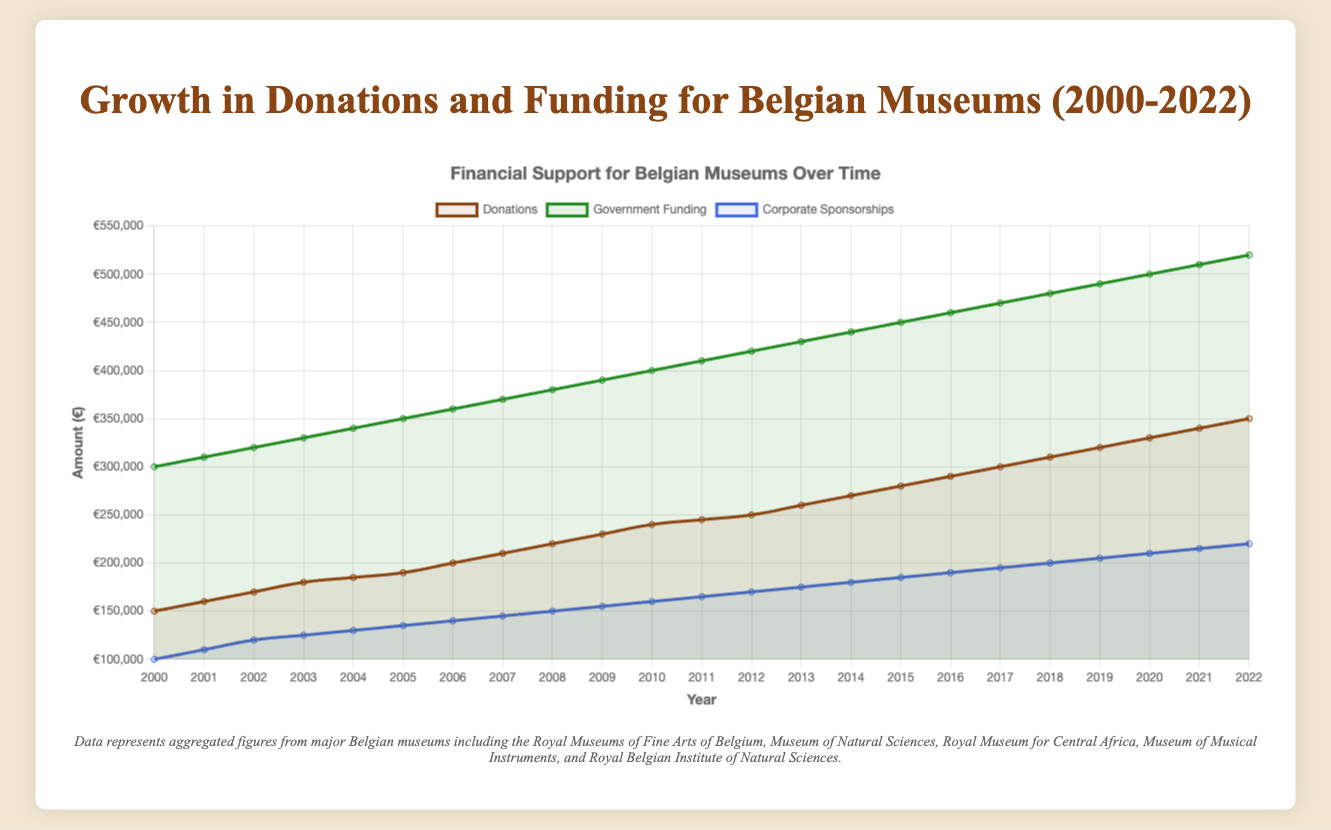What was the total amount of financial support (donations, government funding, and corporate sponsorships) for Belgian museums in 2010? To find the total financial support in 2010, sum up the donations, government funding, and corporate sponsorships for that year: 240,000 + 400,000 + 160,000 = 800,000 €
Answer: 800,000 € Between 2000 and 2022, which type of financial support saw the steepest growth? Compare the increase in donations, government funding, and corporate sponsorships from 2000 to 2022. Donations increased by 200,000 €, government funding by 220,000 €, and corporate sponsorships by 120,000 €. The steepest growth is in government funding.
Answer: Government funding Which year had the highest corporate sponsorships? Look through the data of corporate sponsorships from 2000 to 2022. The highest is in 2022 with 220,000 €.
Answer: 2022 How did donations compare to government funding in 2012? Compare the amounts of donations and government funding in 2012. Donations were 250,000 €, and government funding was 420,000 €, so government funding was higher.
Answer: Government funding was higher What was the average annual government funding between 2000 and 2022? Compute the average government funding by summing all annual government funding amounts from 2000 to 2022 and then dividing by the number of years (23 years): (300,000 + 310,000 + 320,000 + 330,000 + 340,000 + 350,000 + 360,000 + 370,000 + 380,000 + 390,000 + 400,000 + 410,000 + 420,000 + 430,000 + 440,000 + 450,000 + 460,000 + 470,000 + 480,000 + 490,000 + 500,000 + 510,000 + 520,000) / 23 ≈ 413,043.48 €
Answer: 413,043.48 € What is the median amount of corporate sponsorships from 2000 to 2022? To find the median, list the corporate sponsorship amounts from all years in ascending order, then find the middle value. The middle value in a set of 23 numbers is the 12th number when sorted: 100,000, 110,000, 120,000, 125,000, 130,000, 135,000, 140,000, 145,000, 150,000, 155,000, 160,000, (165,000), 170,000, 175,000, 180,000, 185,000, 190,000, 195,000, 200,000, 205,000, 210,000, 215,000, 220,000
Answer: 165,000 € How much did government funding increase from 2000 to 2022? Subtract the government funding in 2000 from the amount in 2022: 520,000 - 300,000 = 220,000 €
Answer: 220,000 € Which source of financial support had the smallest increase between 2000 and 2022? Compare the increase for each type of financial support from 2000 to 2022. Donations increased by 200,000 €, government funding by 220,000 €, and corporate sponsorships by 120,000 €. So, the smallest increase is in corporate sponsorships.
Answer: Corporate sponsorships What percentage of the total financial support in 2020 was contributed by donations? First, calculate the total financial support in 2020: 330,000 + 500,000 + 210,000 = 1,040,000 €. Then, divide the donations by the total and multiply by 100 to get the percentage: (330,000 / 1,040,000) * 100 ≈ 31.73%
Answer: 31.73 % In which years did donations grow by exactly 10,000 €? Examine the year-over-year change in donations from 2000 to 2022. Identified years are: 2000 to 2001 (150,000 to 160,000), 2001 to 2002 (160,000 to 170,000), 2002 to 2003 (170,000 to 180,000), 2003 to 2004 (180,000 to 185,000), 2004 to 2005 (185,000 to 190,000), 2005 to 2006 (190,000 to 200,000), 2006 to 2007 (200,000 to 210,000), 2007 to 2008 (210,000 to 220,000), 2008 to 2009 (220,000 to 230,000), 2009 to 2010 (230,000 to 240,000), 2010 to 2011 (240,000 to 245,000), 2011 to 2012 (245,000 to 250,000), 2012 to 2013 (250,000 to 260,000), 2013 to 2014 (260,000 to 270,000), 2014 to 2015 (270,000 to 280,000), 2015 to 2016 (280,000 to 290,000), 2016 to 2017 (290,000 to 300,000), 2017 to 2018 (300,000 to 310,000), 2018 to 2019 (310,000 to 320,000), 2019 to 2020 (320,000 to 330,000), 2020 to 2021 (330,000 to 340,000), 2021 to 2022 (340,000 to 350,000)
Answer: 2000 to 2022 